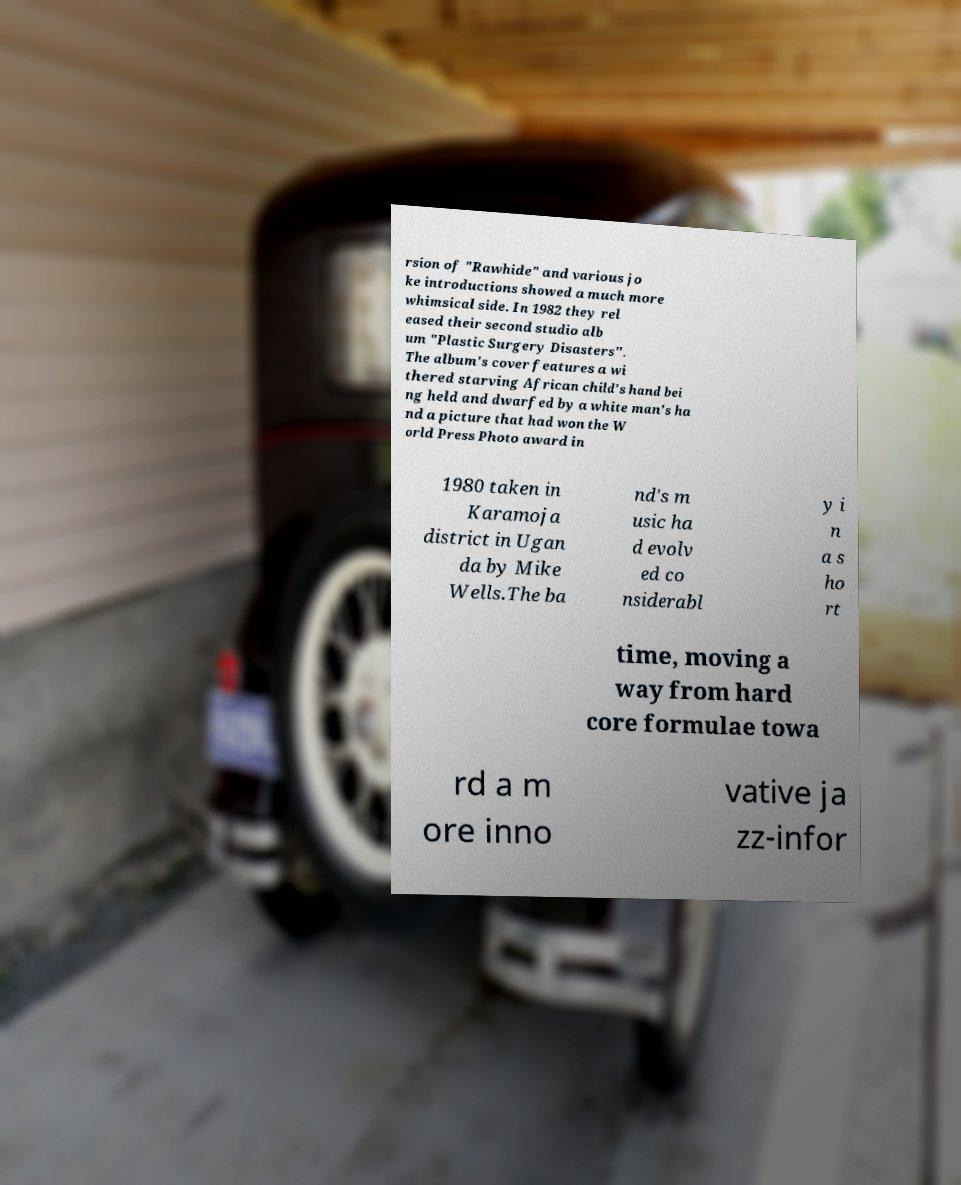Can you accurately transcribe the text from the provided image for me? rsion of "Rawhide" and various jo ke introductions showed a much more whimsical side. In 1982 they rel eased their second studio alb um "Plastic Surgery Disasters". The album's cover features a wi thered starving African child's hand bei ng held and dwarfed by a white man's ha nd a picture that had won the W orld Press Photo award in 1980 taken in Karamoja district in Ugan da by Mike Wells.The ba nd's m usic ha d evolv ed co nsiderabl y i n a s ho rt time, moving a way from hard core formulae towa rd a m ore inno vative ja zz-infor 